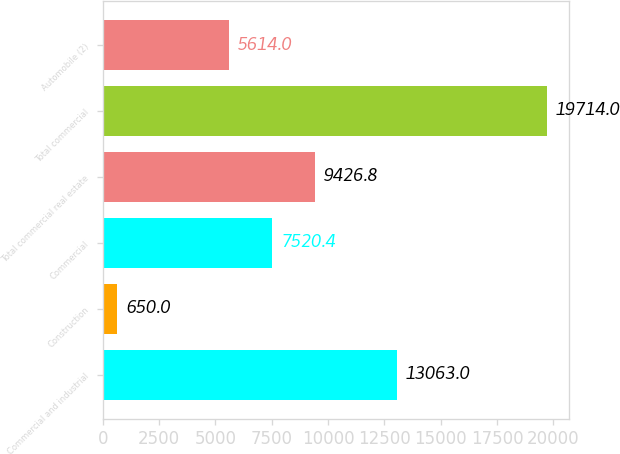Convert chart to OTSL. <chart><loc_0><loc_0><loc_500><loc_500><bar_chart><fcel>Commercial and industrial<fcel>Construction<fcel>Commercial<fcel>Total commercial real estate<fcel>Total commercial<fcel>Automobile (2)<nl><fcel>13063<fcel>650<fcel>7520.4<fcel>9426.8<fcel>19714<fcel>5614<nl></chart> 